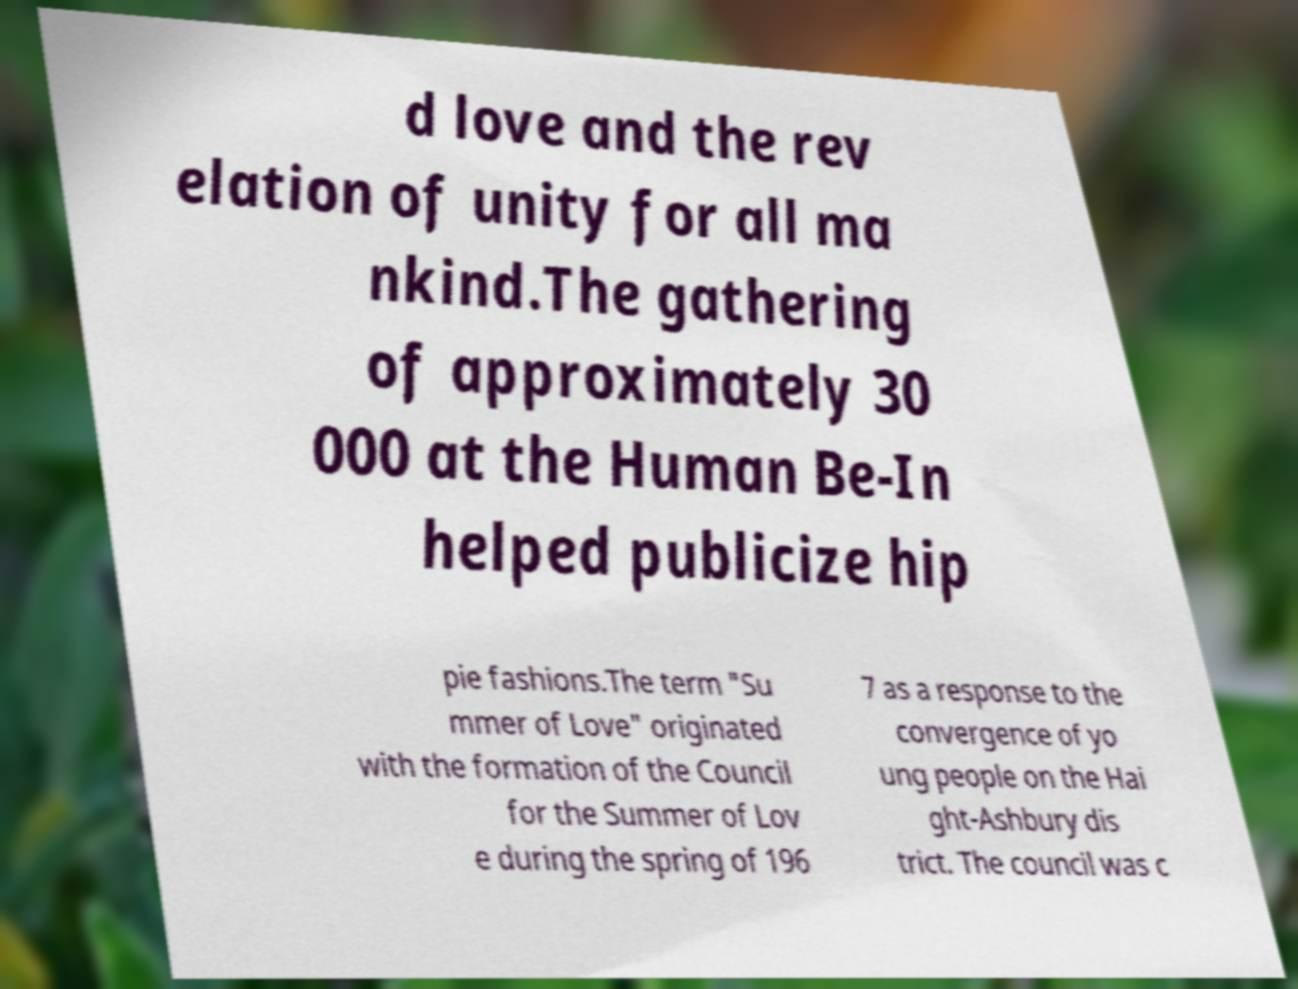What messages or text are displayed in this image? I need them in a readable, typed format. d love and the rev elation of unity for all ma nkind.The gathering of approximately 30 000 at the Human Be-In helped publicize hip pie fashions.The term "Su mmer of Love" originated with the formation of the Council for the Summer of Lov e during the spring of 196 7 as a response to the convergence of yo ung people on the Hai ght-Ashbury dis trict. The council was c 